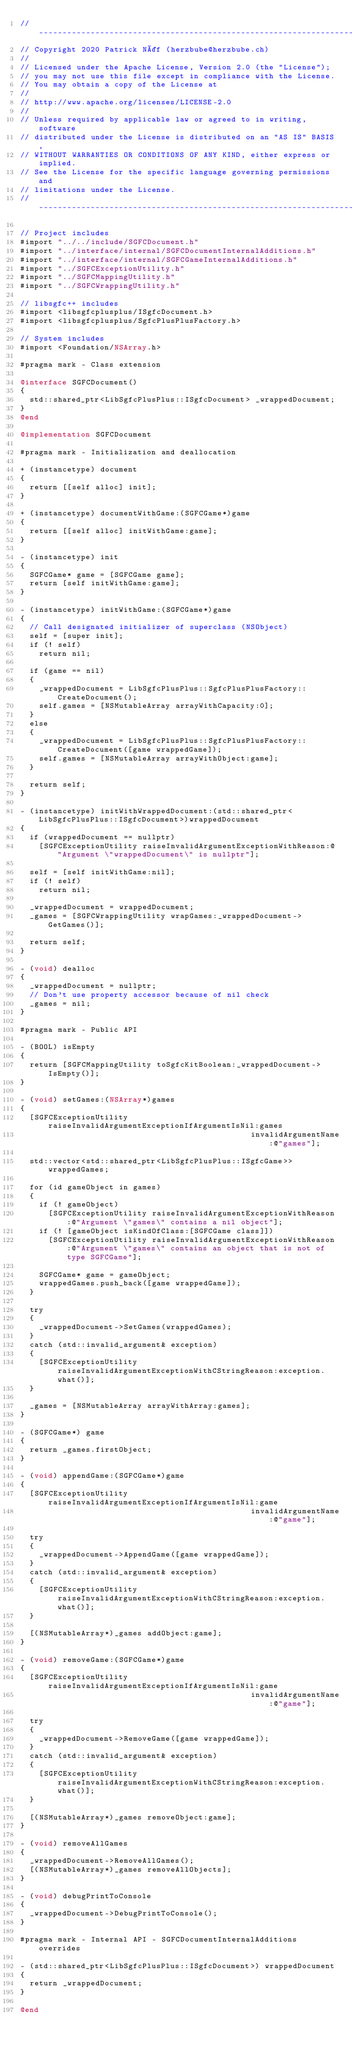<code> <loc_0><loc_0><loc_500><loc_500><_ObjectiveC_>// -----------------------------------------------------------------------------
// Copyright 2020 Patrick Näf (herzbube@herzbube.ch)
//
// Licensed under the Apache License, Version 2.0 (the "License");
// you may not use this file except in compliance with the License.
// You may obtain a copy of the License at
//
// http://www.apache.org/licenses/LICENSE-2.0
//
// Unless required by applicable law or agreed to in writing, software
// distributed under the License is distributed on an "AS IS" BASIS,
// WITHOUT WARRANTIES OR CONDITIONS OF ANY KIND, either express or implied.
// See the License for the specific language governing permissions and
// limitations under the License.
// -----------------------------------------------------------------------------

// Project includes
#import "../../include/SGFCDocument.h"
#import "../interface/internal/SGFCDocumentInternalAdditions.h"
#import "../interface/internal/SGFCGameInternalAdditions.h"
#import "../SGFCExceptionUtility.h"
#import "../SGFCMappingUtility.h"
#import "../SGFCWrappingUtility.h"

// libsgfc++ includes
#import <libsgfcplusplus/ISgfcDocument.h>
#import <libsgfcplusplus/SgfcPlusPlusFactory.h>

// System includes
#import <Foundation/NSArray.h>

#pragma mark - Class extension

@interface SGFCDocument()
{
  std::shared_ptr<LibSgfcPlusPlus::ISgfcDocument> _wrappedDocument;
}
@end

@implementation SGFCDocument

#pragma mark - Initialization and deallocation

+ (instancetype) document
{
  return [[self alloc] init];
}

+ (instancetype) documentWithGame:(SGFCGame*)game
{
  return [[self alloc] initWithGame:game];
}

- (instancetype) init
{
  SGFCGame* game = [SGFCGame game];
  return [self initWithGame:game];
}

- (instancetype) initWithGame:(SGFCGame*)game
{
  // Call designated initializer of superclass (NSObject)
  self = [super init];
  if (! self)
    return nil;

  if (game == nil)
  {
    _wrappedDocument = LibSgfcPlusPlus::SgfcPlusPlusFactory::CreateDocument();
    self.games = [NSMutableArray arrayWithCapacity:0];
  }
  else
  {
    _wrappedDocument = LibSgfcPlusPlus::SgfcPlusPlusFactory::CreateDocument([game wrappedGame]);
    self.games = [NSMutableArray arrayWithObject:game];
  }

  return self;
}

- (instancetype) initWithWrappedDocument:(std::shared_ptr<LibSgfcPlusPlus::ISgfcDocument>)wrappedDocument
{
  if (wrappedDocument == nullptr)
    [SGFCExceptionUtility raiseInvalidArgumentExceptionWithReason:@"Argument \"wrappedDocument\" is nullptr"];

  self = [self initWithGame:nil];
  if (! self)
    return nil;

  _wrappedDocument = wrappedDocument;
  _games = [SGFCWrappingUtility wrapGames:_wrappedDocument->GetGames()];

  return self;
}

- (void) dealloc
{
  _wrappedDocument = nullptr;
  // Don't use property accessor because of nil check
  _games = nil;
}

#pragma mark - Public API

- (BOOL) isEmpty
{
  return [SGFCMappingUtility toSgfcKitBoolean:_wrappedDocument->IsEmpty()];
}

- (void) setGames:(NSArray*)games
{
  [SGFCExceptionUtility raiseInvalidArgumentExceptionIfArgumentIsNil:games
                                                 invalidArgumentName:@"games"];

  std::vector<std::shared_ptr<LibSgfcPlusPlus::ISgfcGame>> wrappedGames;

  for (id gameObject in games)
  {
    if (! gameObject)
      [SGFCExceptionUtility raiseInvalidArgumentExceptionWithReason:@"Argument \"games\" contains a nil object"];
    if (! [gameObject isKindOfClass:[SGFCGame class]])
      [SGFCExceptionUtility raiseInvalidArgumentExceptionWithReason:@"Argument \"games\" contains an object that is not of type SGFCGame"];

    SGFCGame* game = gameObject;
    wrappedGames.push_back([game wrappedGame]);
  }

  try
  {
    _wrappedDocument->SetGames(wrappedGames);
  }
  catch (std::invalid_argument& exception)
  {
    [SGFCExceptionUtility raiseInvalidArgumentExceptionWithCStringReason:exception.what()];
  }

  _games = [NSMutableArray arrayWithArray:games];
}

- (SGFCGame*) game
{
  return _games.firstObject;
}

- (void) appendGame:(SGFCGame*)game
{
  [SGFCExceptionUtility raiseInvalidArgumentExceptionIfArgumentIsNil:game
                                                 invalidArgumentName:@"game"];

  try
  {
    _wrappedDocument->AppendGame([game wrappedGame]);
  }
  catch (std::invalid_argument& exception)
  {
    [SGFCExceptionUtility raiseInvalidArgumentExceptionWithCStringReason:exception.what()];
  }

  [(NSMutableArray*)_games addObject:game];
}

- (void) removeGame:(SGFCGame*)game
{
  [SGFCExceptionUtility raiseInvalidArgumentExceptionIfArgumentIsNil:game
                                                 invalidArgumentName:@"game"];

  try
  {
    _wrappedDocument->RemoveGame([game wrappedGame]);
  }
  catch (std::invalid_argument& exception)
  {
    [SGFCExceptionUtility raiseInvalidArgumentExceptionWithCStringReason:exception.what()];
  }

  [(NSMutableArray*)_games removeObject:game];
}

- (void) removeAllGames
{
  _wrappedDocument->RemoveAllGames();
  [(NSMutableArray*)_games removeAllObjects];
}

- (void) debugPrintToConsole
{
  _wrappedDocument->DebugPrintToConsole();
}

#pragma mark - Internal API - SGFCDocumentInternalAdditions overrides

- (std::shared_ptr<LibSgfcPlusPlus::ISgfcDocument>) wrappedDocument
{
  return _wrappedDocument;
}

@end
</code> 